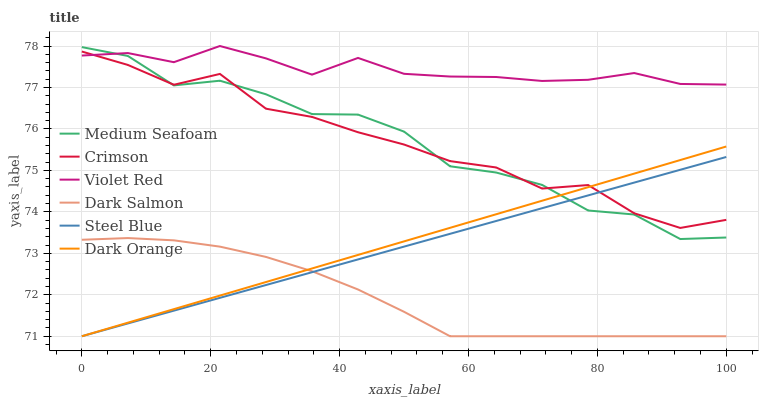Does Dark Salmon have the minimum area under the curve?
Answer yes or no. Yes. Does Violet Red have the maximum area under the curve?
Answer yes or no. Yes. Does Steel Blue have the minimum area under the curve?
Answer yes or no. No. Does Steel Blue have the maximum area under the curve?
Answer yes or no. No. Is Steel Blue the smoothest?
Answer yes or no. Yes. Is Medium Seafoam the roughest?
Answer yes or no. Yes. Is Violet Red the smoothest?
Answer yes or no. No. Is Violet Red the roughest?
Answer yes or no. No. Does Dark Orange have the lowest value?
Answer yes or no. Yes. Does Violet Red have the lowest value?
Answer yes or no. No. Does Violet Red have the highest value?
Answer yes or no. Yes. Does Steel Blue have the highest value?
Answer yes or no. No. Is Dark Salmon less than Medium Seafoam?
Answer yes or no. Yes. Is Violet Red greater than Dark Orange?
Answer yes or no. Yes. Does Medium Seafoam intersect Dark Orange?
Answer yes or no. Yes. Is Medium Seafoam less than Dark Orange?
Answer yes or no. No. Is Medium Seafoam greater than Dark Orange?
Answer yes or no. No. Does Dark Salmon intersect Medium Seafoam?
Answer yes or no. No. 